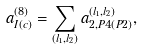Convert formula to latex. <formula><loc_0><loc_0><loc_500><loc_500>a _ { I ( c ) } ^ { ( 8 ) } = \sum _ { ( l _ { 1 } , l _ { 2 } ) } a _ { 2 , P 4 ( P 2 ) } ^ { ( l _ { 1 } , l _ { 2 } ) } ,</formula> 